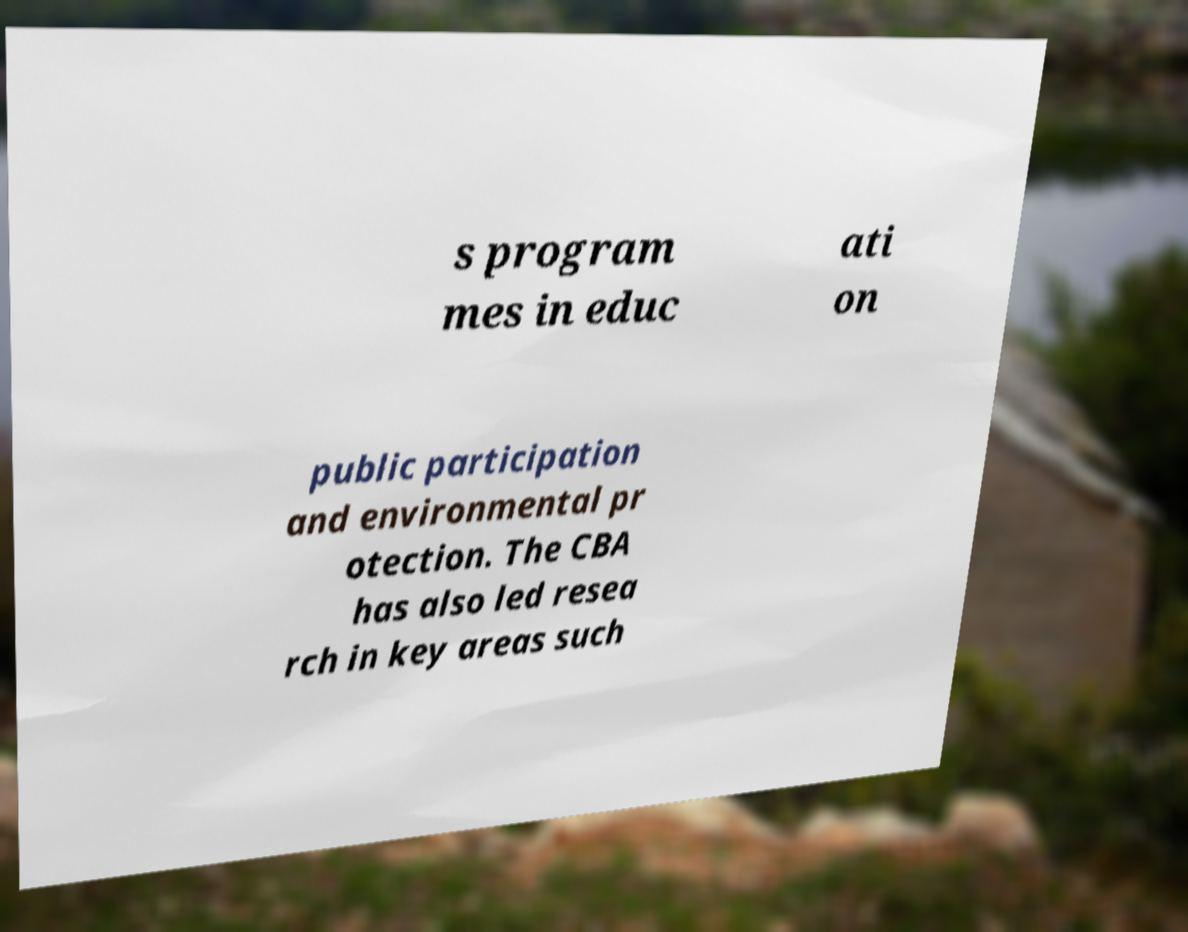Please identify and transcribe the text found in this image. s program mes in educ ati on public participation and environmental pr otection. The CBA has also led resea rch in key areas such 